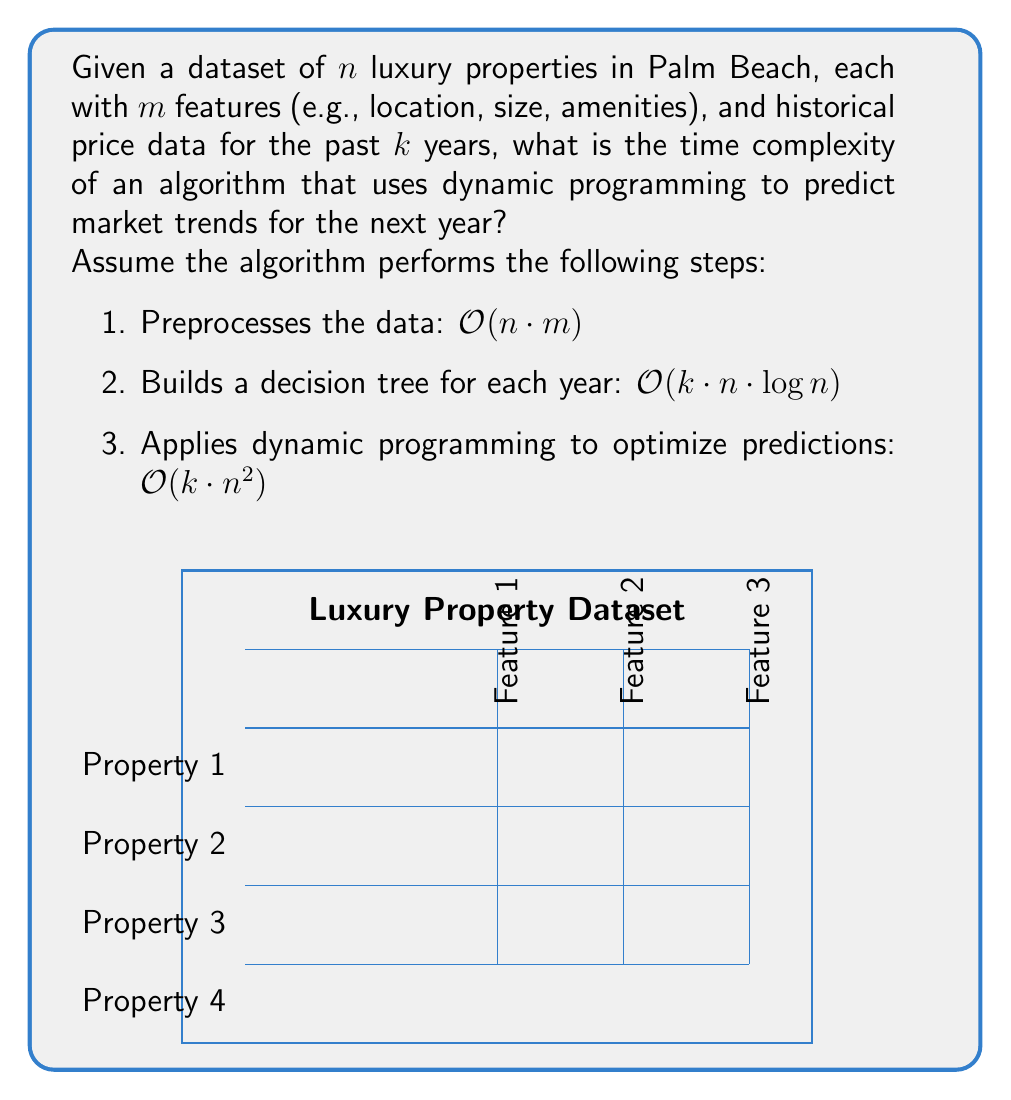Could you help me with this problem? To determine the overall time complexity, we need to analyze each step of the algorithm and combine them:

1. Preprocessing: $O(n \cdot m)$
   This step involves processing each feature of every property once.

2. Building decision trees: $O(k \cdot n \cdot \log n)$
   For each of the $k$ years, we build a decision tree with $n$ nodes, which typically has a complexity of $O(n \cdot \log n)$.

3. Dynamic programming: $O(k \cdot n^2)$
   This step involves comparing each property with every other property for each year.

To find the overall time complexity, we need to sum these components:

$$O(n \cdot m) + O(k \cdot n \cdot \log n) + O(k \cdot n^2)$$

We can simplify this by considering the dominant term. Since $n^2$ grows faster than $n \cdot \log n$ and $n \cdot m$ (assuming $m$ is relatively small compared to $n$), the $O(k \cdot n^2)$ term dominates.

Therefore, the overall time complexity of the algorithm is $O(k \cdot n^2)$.
Answer: $O(k \cdot n^2)$ 